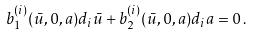<formula> <loc_0><loc_0><loc_500><loc_500>b _ { 1 } ^ { ( i ) } ( \bar { u } , 0 , a ) d _ { i } \bar { u } + b _ { 2 } ^ { ( i ) } ( \bar { u } , 0 , a ) d _ { i } a = 0 \, .</formula> 